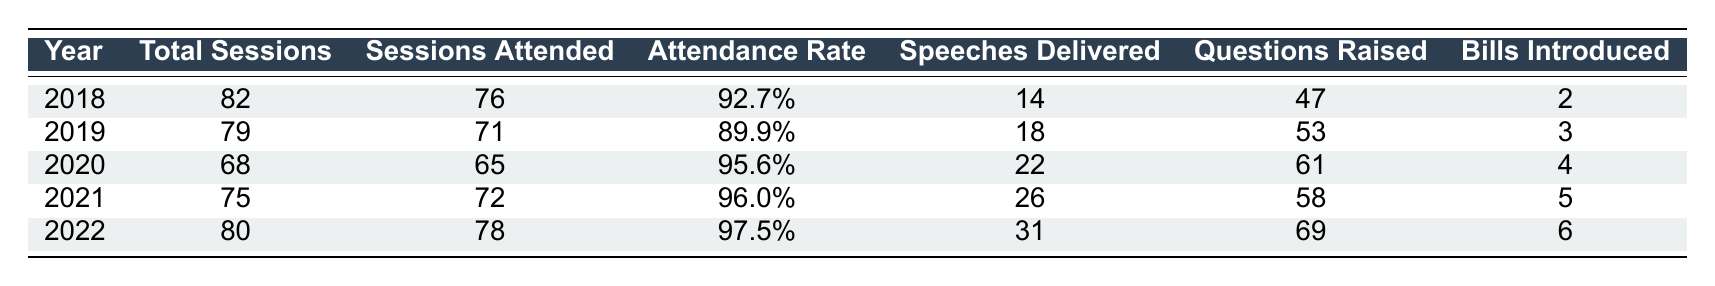What was Rajesh Faldessai's attendance rate in 2021? The table shows the attendance rate for 2021 is listed next to that year. The attendance rate for 2021 is 96.0%.
Answer: 96.0% How many sessions did Rajesh Faldessai attend in 2019? Looking at the data for 2019, the number of sessions attended is directly provided. Rajesh attended 71 sessions in 2019.
Answer: 71 Which year had the highest number of speeches delivered by Rajesh Faldessai? By checking the number of speeches delivered across the years, 2022 has the highest number with 31 speeches.
Answer: 2022 What is the difference between the total sessions and sessions attended in 2020? The total sessions in 2020 are 68 and sessions attended are 65. The difference is calculated as 68 - 65, which equals 3.
Answer: 3 Did Rajesh Faldessai raise more questions in 2020 than in 2018? In 2020, he raised 61 questions, while in 2018 he raised 47 questions. Since 61 is greater than 47, he raised more questions in 2020.
Answer: Yes What was the average attendance rate over the years 2018 to 2022? First, we sum the attendance rates as percentages: 92.7 + 89.9 + 95.6 + 96.0 + 97.5 = 471.7. Then we divide by 5 (the number of years), resulting in an average of 94.34%.
Answer: 94.34% How many bills did Rajesh Faldessai introduce in total from 2018 to 2022? Adding the number of bills introduced each year gives: 2 + 3 + 4 + 5 + 6 = 20. Therefore, the total bills introduced from 2018 to 2022 is 20.
Answer: 20 Which year had the lower attendance rate: 2019 or 2021? The attendance rates are 89.9% for 2019 and 96.0% for 2021. Since 89.9% is lower than 96.0%, 2019 had the lower attendance rate.
Answer: 2019 In which year did Rajesh deliver the least number of speeches? By comparing the speeches delivered, 2018 has the least with 14 speeches compared to other years.
Answer: 2018 What was the total number of sessions held from 2018 to 2022? Adding the total sessions each year gives: 82 + 79 + 68 + 75 + 80 = 384 sessions held.
Answer: 384 